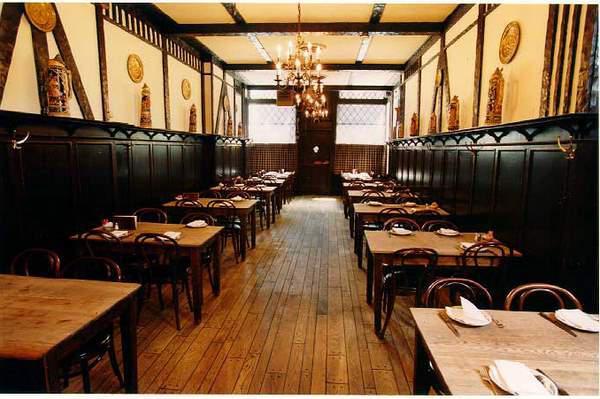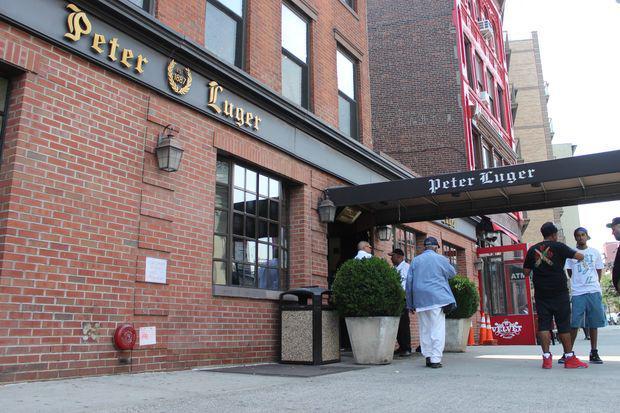The first image is the image on the left, the second image is the image on the right. Assess this claim about the two images: "The right image shows at least one person in front of a black roof that extends out from a red brick building.". Correct or not? Answer yes or no. Yes. 